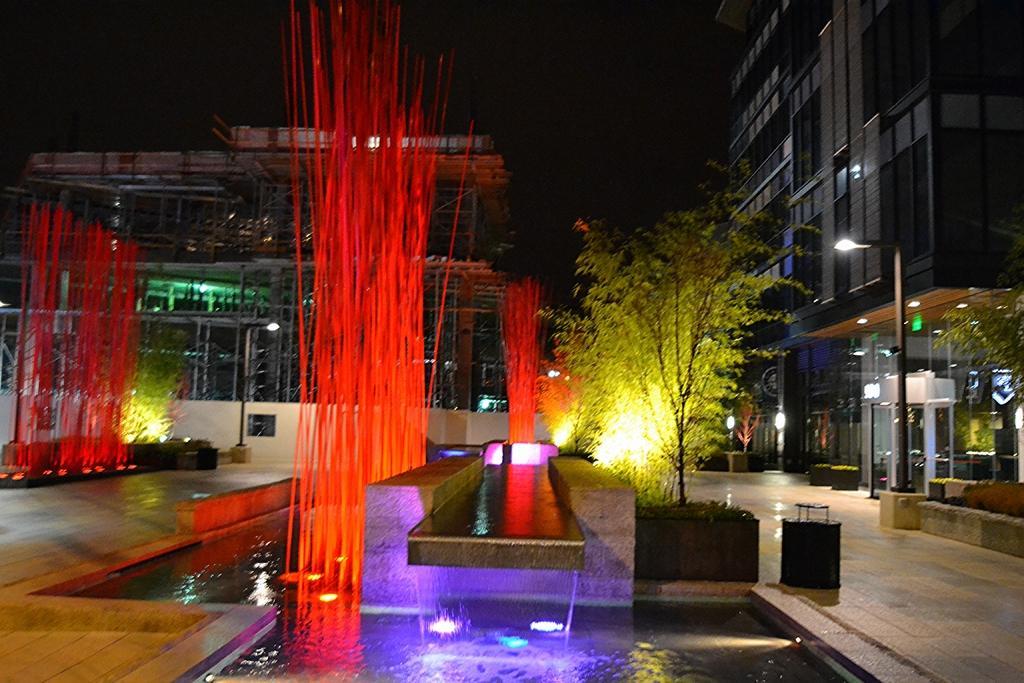Please provide a concise description of this image. In the given image i can see a buildings with windows,electric lights,plants,water and some decorative objects. 